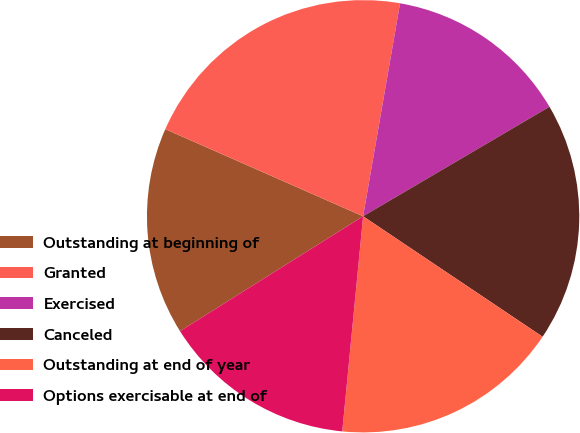Convert chart. <chart><loc_0><loc_0><loc_500><loc_500><pie_chart><fcel>Outstanding at beginning of<fcel>Granted<fcel>Exercised<fcel>Canceled<fcel>Outstanding at end of year<fcel>Options exercisable at end of<nl><fcel>15.52%<fcel>21.13%<fcel>13.81%<fcel>17.86%<fcel>17.13%<fcel>14.54%<nl></chart> 